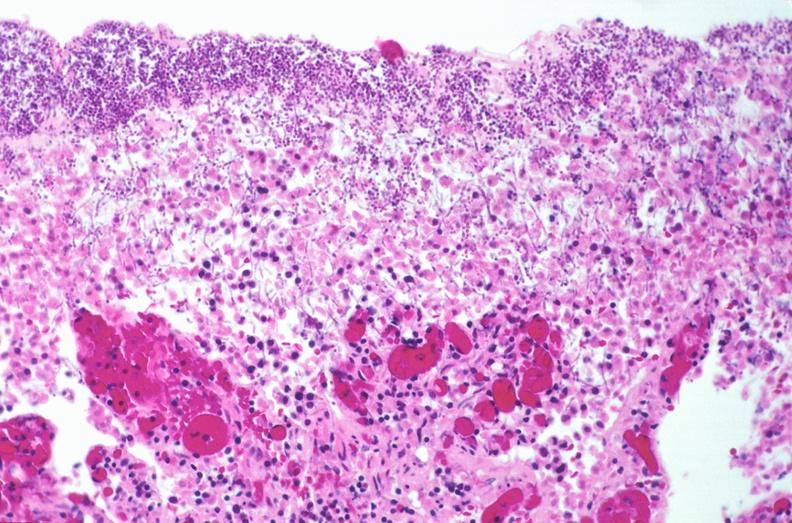does dysplastic show duodenum, necrotizing enteritis with pseudomembrane, candida?
Answer the question using a single word or phrase. No 